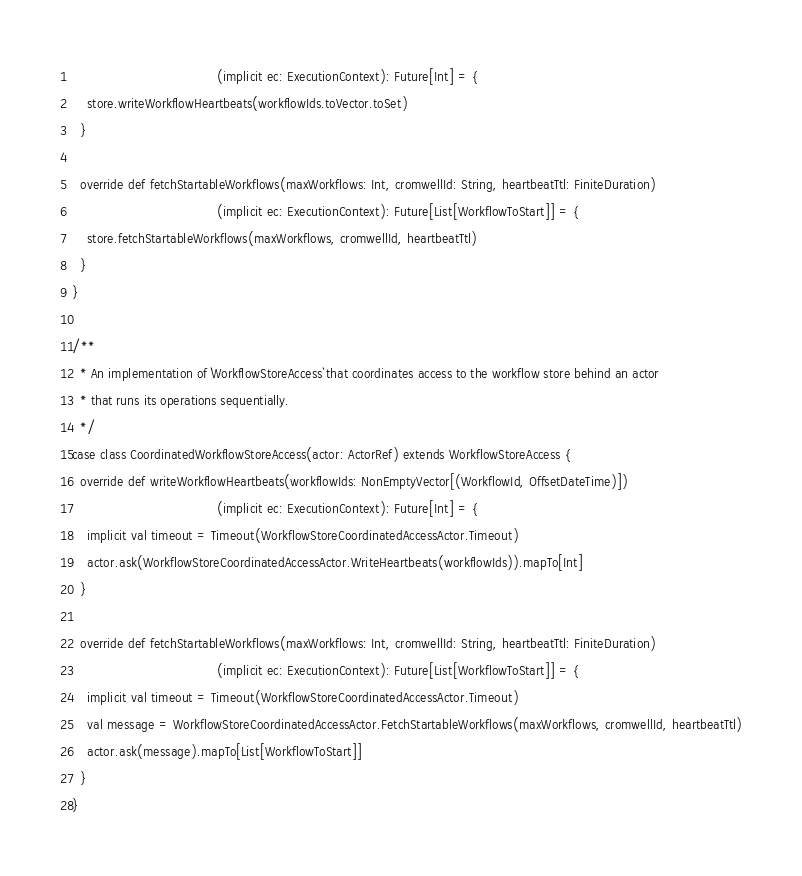<code> <loc_0><loc_0><loc_500><loc_500><_Scala_>                                      (implicit ec: ExecutionContext): Future[Int] = {
    store.writeWorkflowHeartbeats(workflowIds.toVector.toSet)
  }

  override def fetchStartableWorkflows(maxWorkflows: Int, cromwellId: String, heartbeatTtl: FiniteDuration)
                                      (implicit ec: ExecutionContext): Future[List[WorkflowToStart]] = {
    store.fetchStartableWorkflows(maxWorkflows, cromwellId, heartbeatTtl)
  }
}

/**
  * An implementation of `WorkflowStoreAccess` that coordinates access to the workflow store behind an actor
  * that runs its operations sequentially.
  */
case class CoordinatedWorkflowStoreAccess(actor: ActorRef) extends WorkflowStoreAccess {
  override def writeWorkflowHeartbeats(workflowIds: NonEmptyVector[(WorkflowId, OffsetDateTime)])
                                      (implicit ec: ExecutionContext): Future[Int] = {
    implicit val timeout = Timeout(WorkflowStoreCoordinatedAccessActor.Timeout)
    actor.ask(WorkflowStoreCoordinatedAccessActor.WriteHeartbeats(workflowIds)).mapTo[Int]
  }

  override def fetchStartableWorkflows(maxWorkflows: Int, cromwellId: String, heartbeatTtl: FiniteDuration)
                                      (implicit ec: ExecutionContext): Future[List[WorkflowToStart]] = {
    implicit val timeout = Timeout(WorkflowStoreCoordinatedAccessActor.Timeout)
    val message = WorkflowStoreCoordinatedAccessActor.FetchStartableWorkflows(maxWorkflows, cromwellId, heartbeatTtl)
    actor.ask(message).mapTo[List[WorkflowToStart]]
  }
}

</code> 